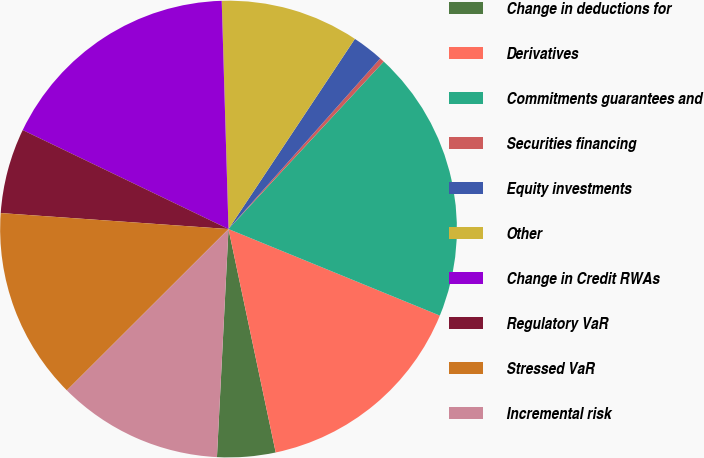Convert chart. <chart><loc_0><loc_0><loc_500><loc_500><pie_chart><fcel>Change in deductions for<fcel>Derivatives<fcel>Commitments guarantees and<fcel>Securities financing<fcel>Equity investments<fcel>Other<fcel>Change in Credit RWAs<fcel>Regulatory VaR<fcel>Stressed VaR<fcel>Incremental risk<nl><fcel>4.12%<fcel>15.5%<fcel>19.29%<fcel>0.33%<fcel>2.23%<fcel>9.81%<fcel>17.39%<fcel>6.02%<fcel>13.6%<fcel>11.71%<nl></chart> 